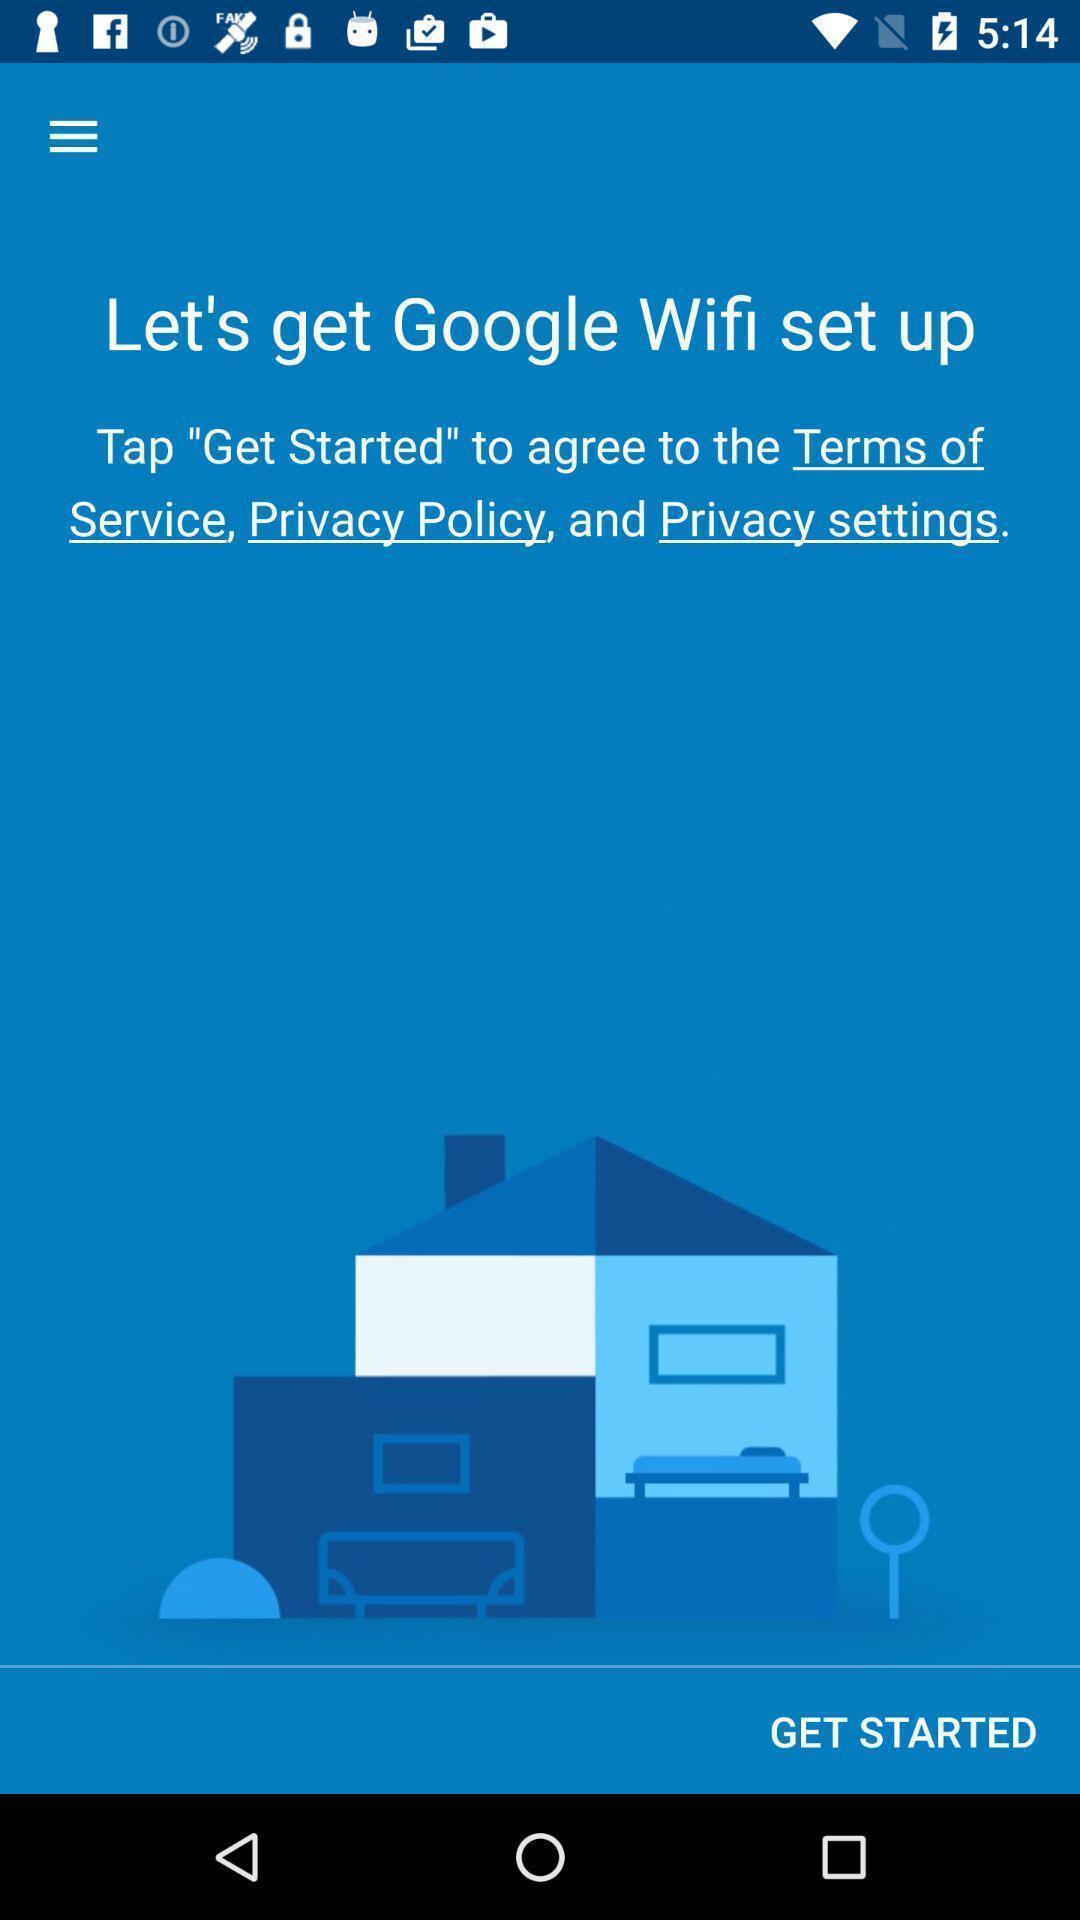Give me a narrative description of this picture. Welcome page with get started option. 